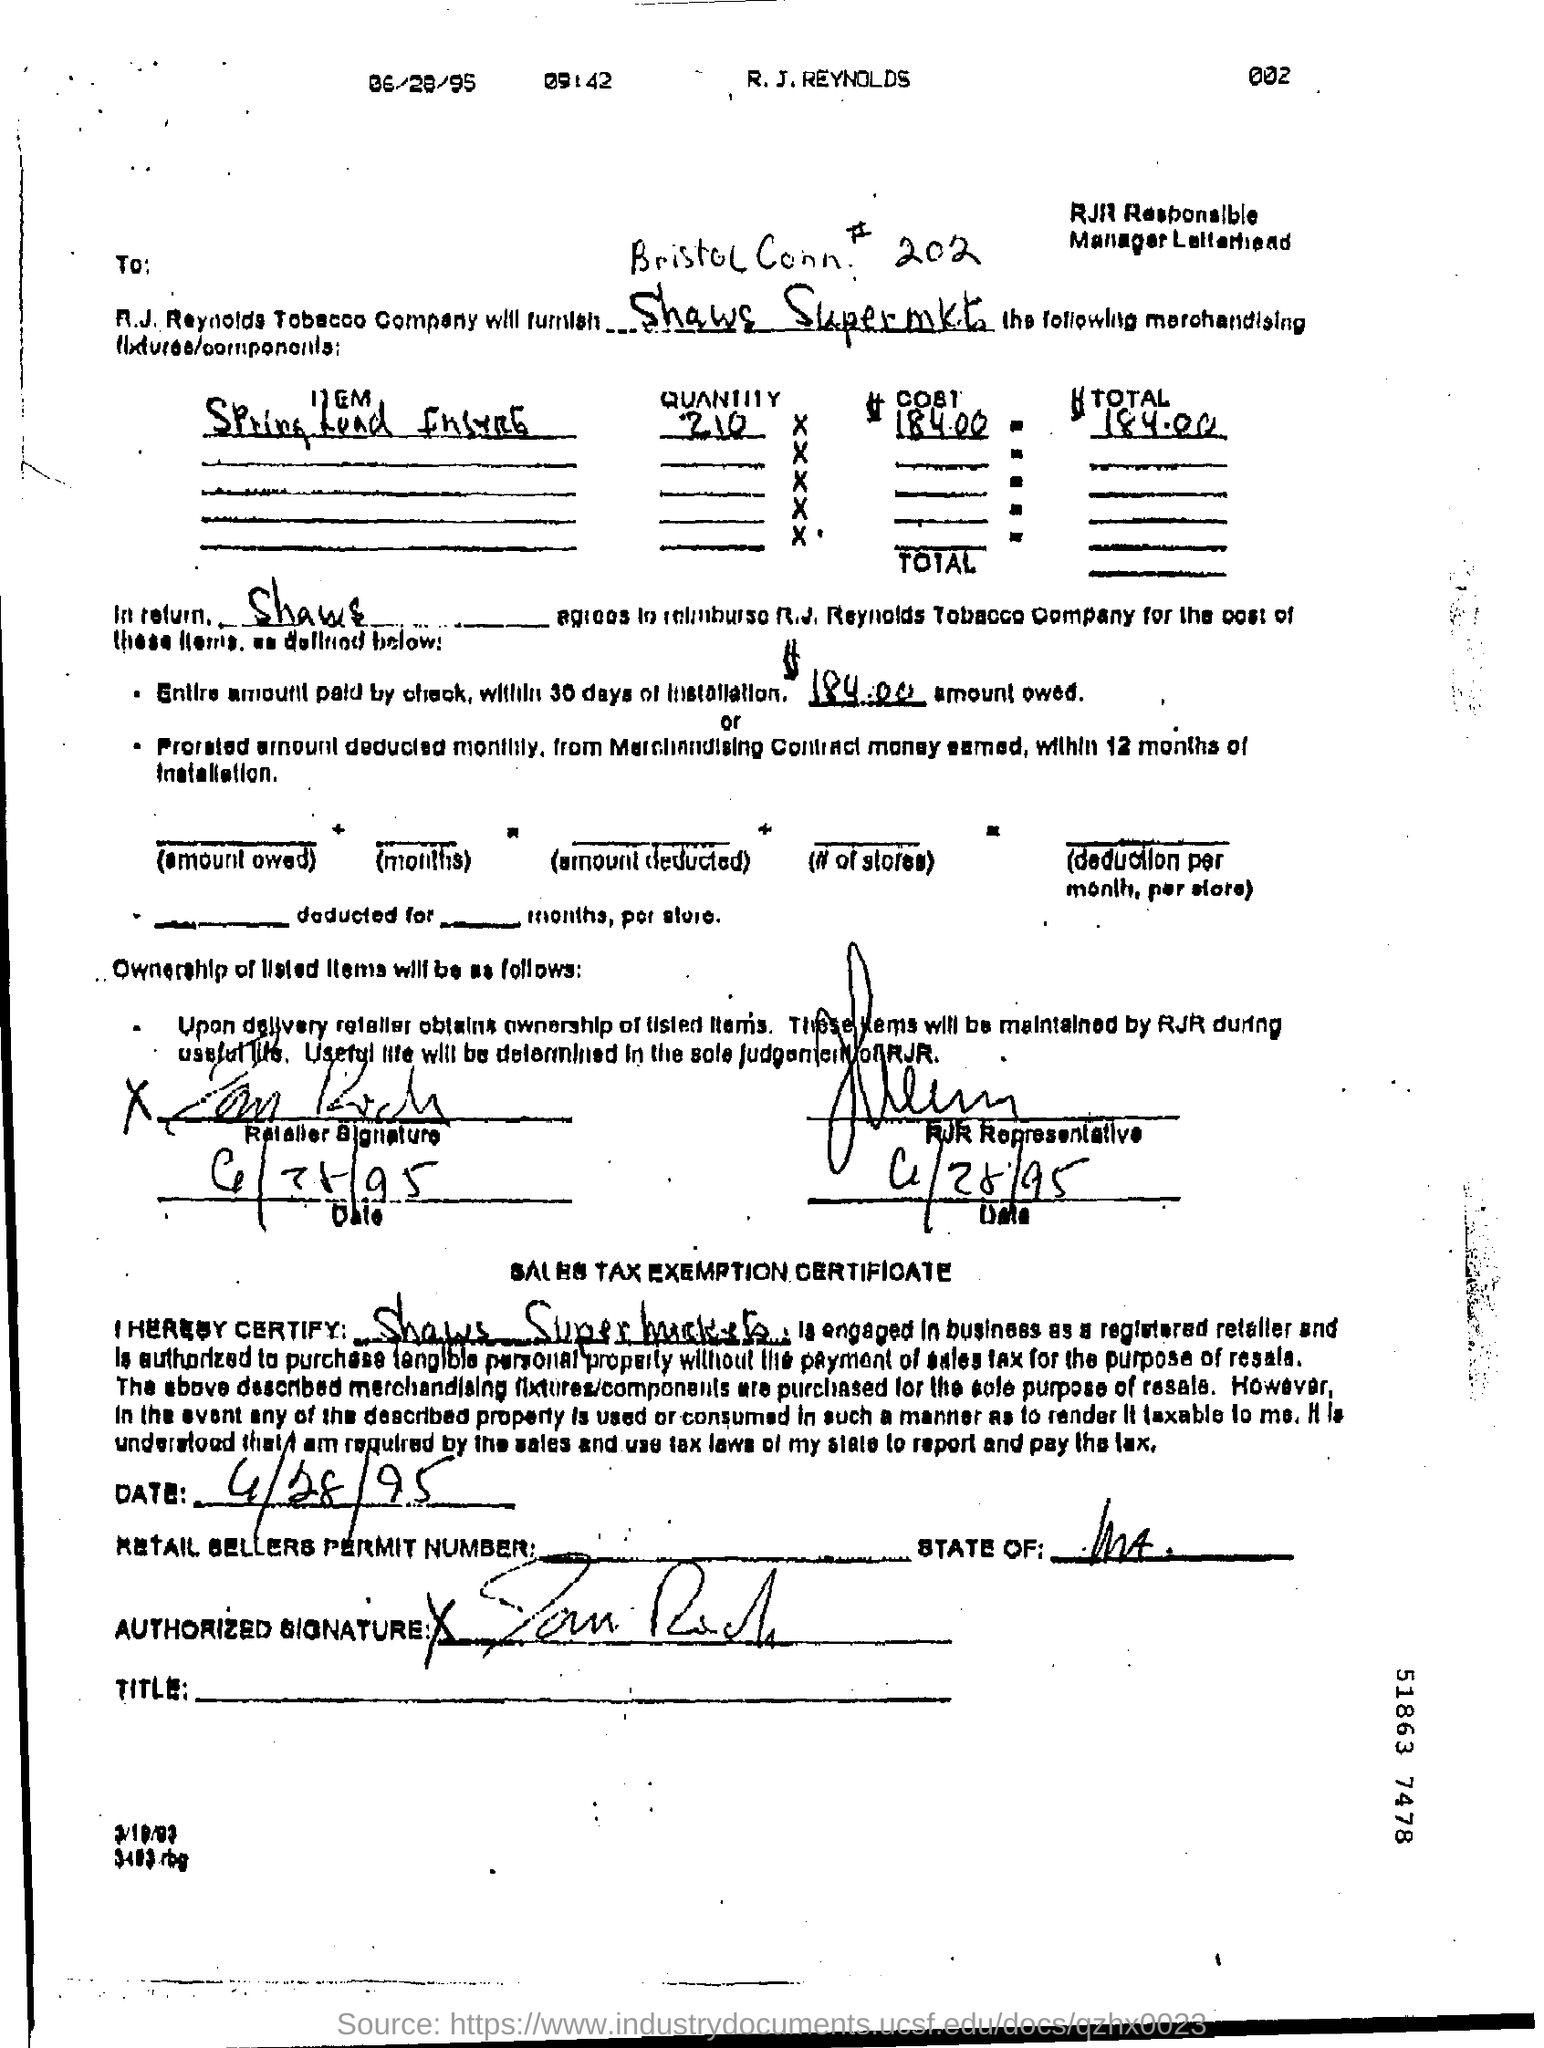What is the total amount?
Provide a succinct answer. 184.00. 